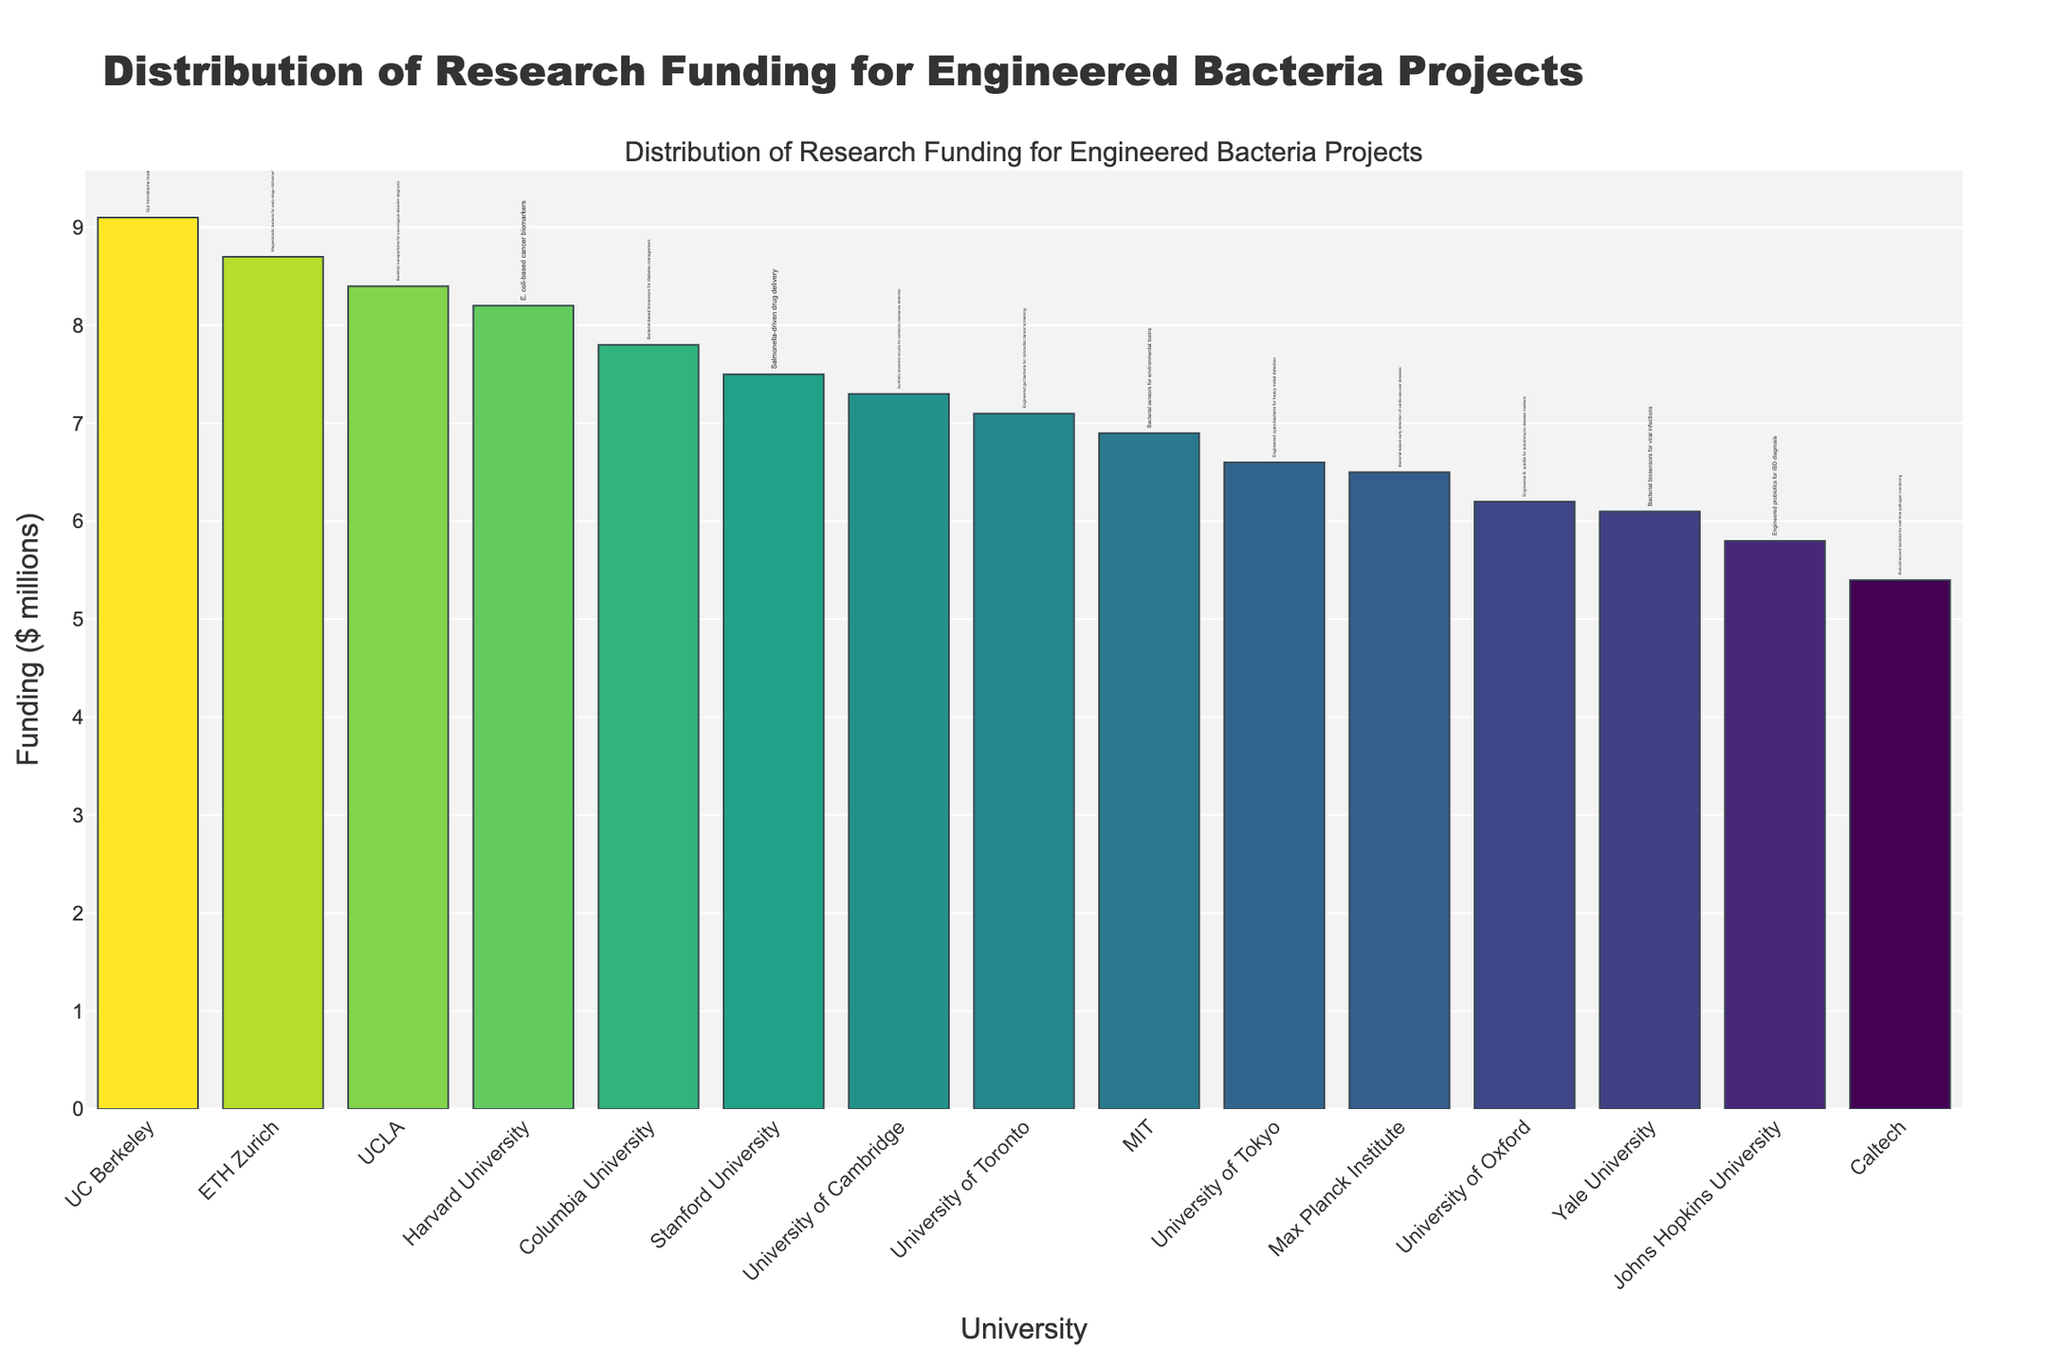Which university received the highest funding for their engineered bacteria project? The bar chart shows different funding amounts for various universities. Identifying the tallest bar indicates the highest funding.
Answer: UC Berkeley What is the funding difference between the highest-funded and lowest-funded projects? The highest funding is for UC Berkeley ($9.1 million), and the lowest is for Caltech ($5.4 million). Subtracting these two values gives the funding difference: $9.1 million - $5.4 million = $3.7 million.
Answer: $3.7 million Which universities received more than $8 million in funding for their projects? From the bar heights and their respective labels, the bars reaching above the $8 million mark correspond to the universities' names.
Answer: UC Berkeley, Harvard University, ETH Zurich, UCLA What are the funding amounts for the universities with projects on diabetes management and autoimmune disease markers? Identify the universities and their corresponding project names. Columbia University has a project on diabetes management ($7.8 million), and the University of Oxford on autoimmune disease markers ($6.2 million).
Answer: Columbia University: $7.8 million, University of Oxford: $6.2 million Which project has a higher funding, engineered probiotics for IBD diagnosis or bioluminescent bacteria for real-time pathogen monitoring? Comparing the corresponding bars for Johns Hopkins University and Caltech, Johns Hopkins received $5.8 million for IBD diagnosis and Caltech received $5.4 million for pathogen monitoring.
Answer: Engineered probiotics for IBD diagnosis What is the total funding for the projects from Harvard University, Stanford University, and MIT? Sum the funding amounts of these universities: Harvard University ($8.2 million), Stanford University ($7.5 million), MIT ($6.9 million). The total is $8.2 million + $7.5 million + $6.9 million = $22.6 million.
Answer: $22.6 million How does the funding for bacterial biosensors for viral infections compare with bacterial-based biosensors for diabetes management? Yale University, with bacterial biosensors for viral infections, has $6.1 million, and Columbia University, with biosensors for diabetes management, has $7.8 million. Columbia University received more funding.
Answer: Columbia University received more funding Which university has the highest funded project related to neurological disorder diagnosis? Look at the project descriptions and find the one related to neurological disorders, then compare its funding. UCLA’s project on neurological disorder diagnosis received $8.4 million, which is the highest in that category.
Answer: UCLA What is the average funding across all engineered bacteria projects listed in the figure? Sum all the funding amounts and divide by the number of universities (15). The sum is $7.1+$9.1+$5.8+$8.2+$7.5+$7.3+$6.1+$8.7+$5.4+$6.6+$7.8+$6.2+$8.4+$7.1+$6.5, which equals $109.7 million. Average funding = $109.7 million / 15 ≈ $7.31 million.
Answer: $7.31 million 